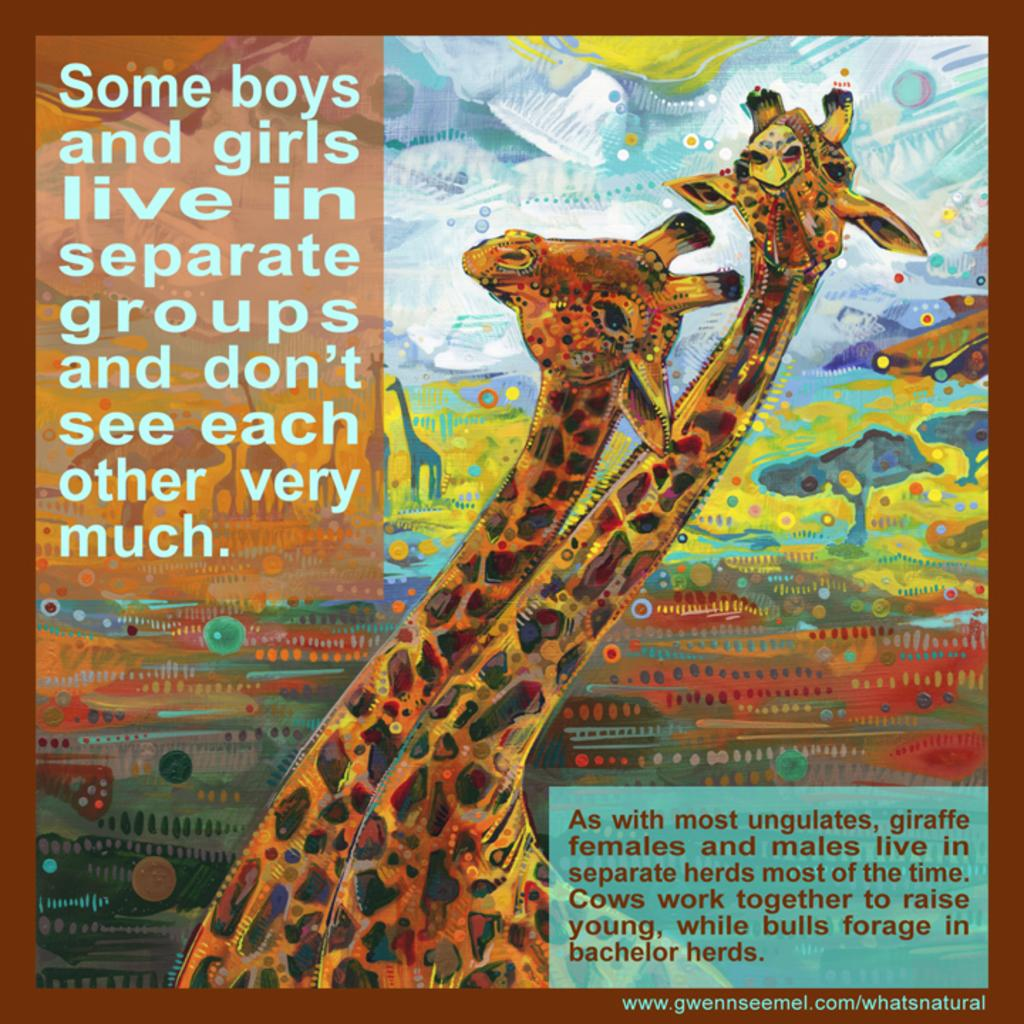What is depicted on the poster in the image? The poster contains sketches of giraffes and trees. Where is the text located on the poster? There is text at the top left and bottom right of the poster. What attempt at a scientific experiment can be seen in the middle of the image? There is no attempt at a scientific experiment present in the image; it only features a poster with sketches of giraffes and trees and text at the top left and bottom right. 